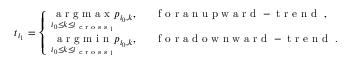Convert formula to latex. <formula><loc_0><loc_0><loc_500><loc_500>t _ { i _ { 1 } } = \left \{ \begin{array} { l l } { \underset { i _ { 0 } \leq k \leq i _ { c r o s s _ { 1 } } } { \arg \max } p _ { i _ { 0 } , k } , } & { { f o r a n u p w a r d - t r e n d } , } \\ { \underset { { i _ { 0 } \leq k \leq i _ { c r o s s _ { 1 } } } } { \arg \min } p _ { i _ { 0 } , k } , } & { { f o r a d o w n w a r d - t r e n d } . } \end{array}</formula> 